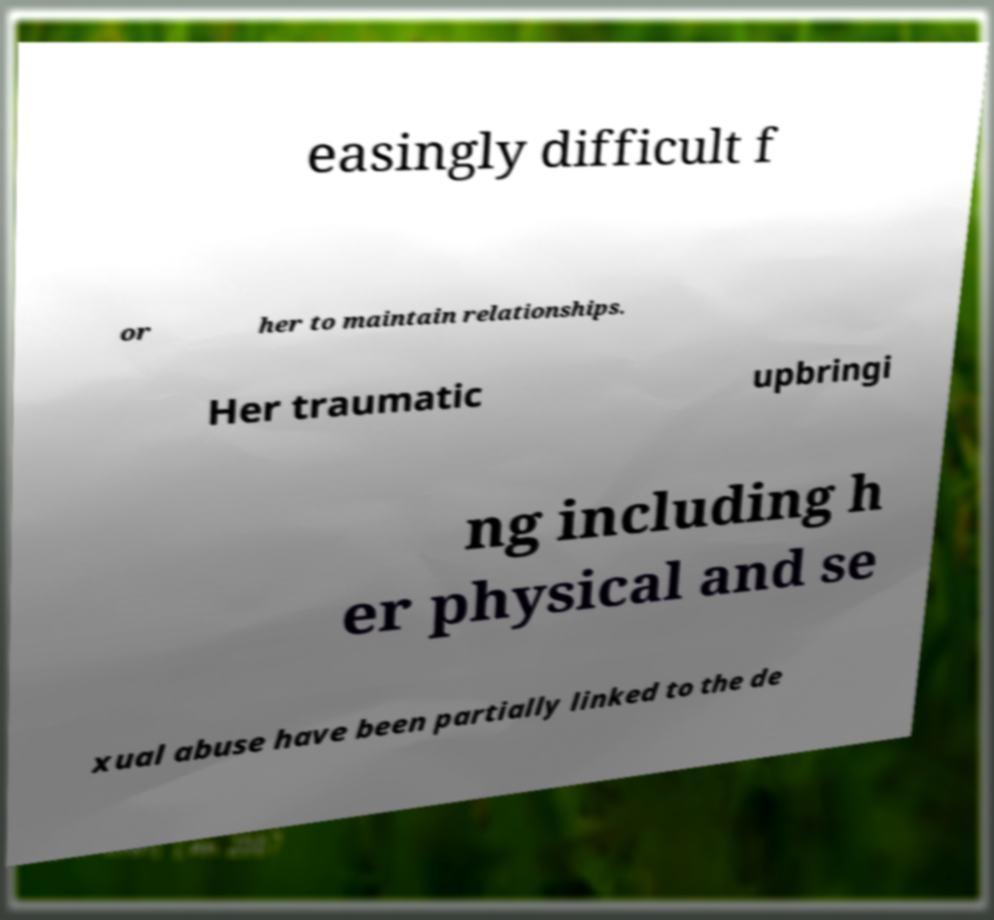Could you assist in decoding the text presented in this image and type it out clearly? easingly difficult f or her to maintain relationships. Her traumatic upbringi ng including h er physical and se xual abuse have been partially linked to the de 